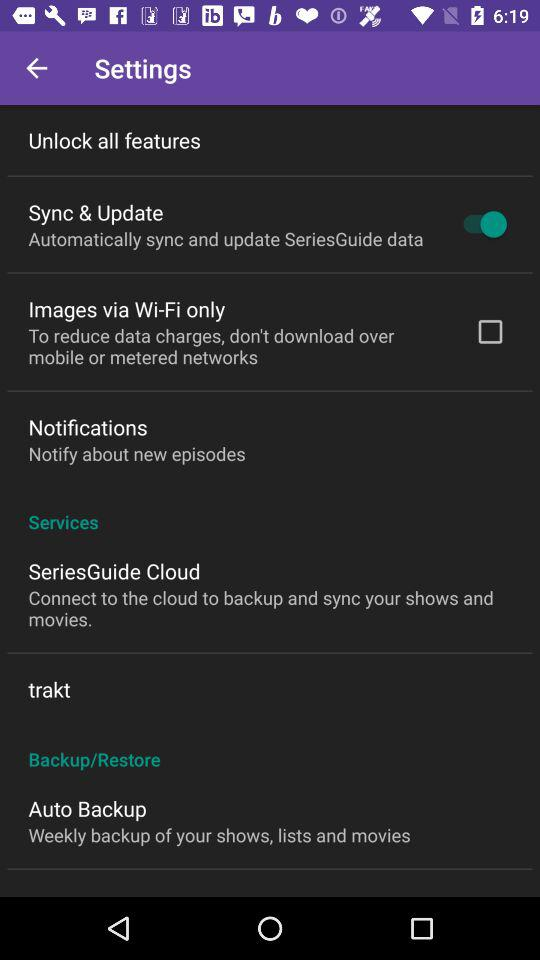Can updates for the SeriesGuide app be limited to Wi-Fi only? Yes, updates for the SeriesGuide app can be restricted to Wi-Fi only. This option is available in the settings and is currently disabled, allowing downloads over mobile networks as well. 